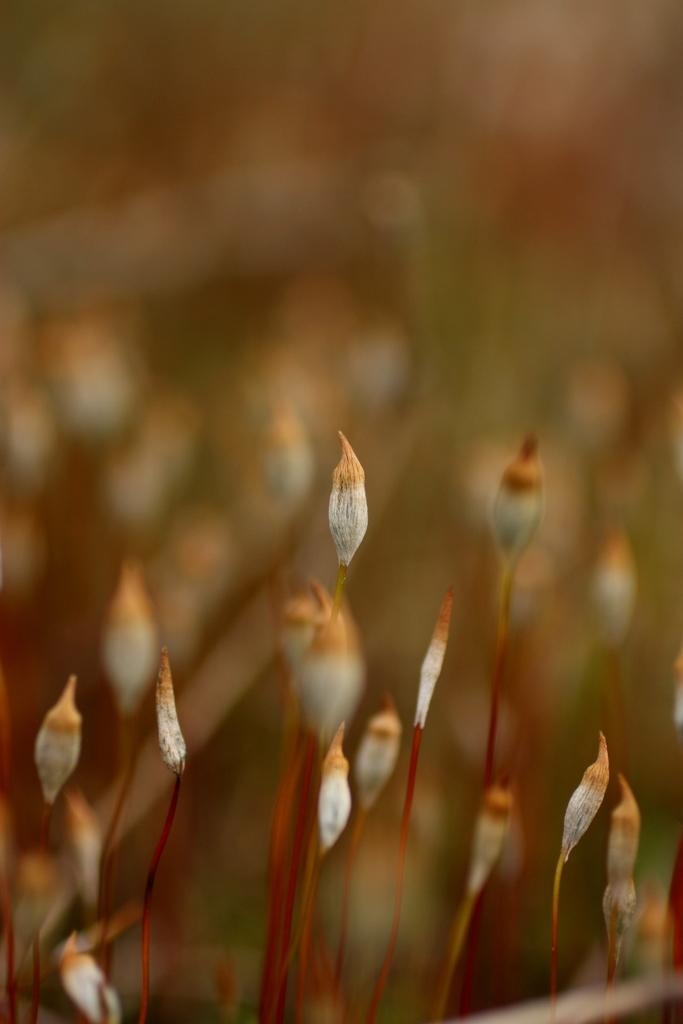What is the main subject of the image? The main subject of the image is a plant. Can you describe the plant in more detail? Unfortunately, the image is a zoomed-in picture of the plant, so it's difficult to provide more specific details about the plant itself. What type of home can be seen in the background of the image? There is no home present in the image, as it is a zoomed-in picture of a plant. Can you tell me how many gravestones are visible in the image? There are no gravestones or cemetery elements present in the image, as it is a zoomed-in picture of a plant. 